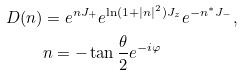<formula> <loc_0><loc_0><loc_500><loc_500>D ( n ) & = e ^ { n J _ { + } } e ^ { \ln ( 1 + | n | ^ { 2 } ) J _ { z } } e ^ { - n ^ { * } J _ { - } } , \\ & n = - \tan \frac { \theta } { 2 } e ^ { - i \varphi }</formula> 